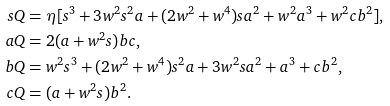Convert formula to latex. <formula><loc_0><loc_0><loc_500><loc_500>s Q & = \eta [ s ^ { 3 } + 3 w ^ { 2 } s ^ { 2 } a + ( 2 w ^ { 2 } + w ^ { 4 } ) s a ^ { 2 } + w ^ { 2 } a ^ { 3 } + w ^ { 2 } c b ^ { 2 } ] , \\ a Q & = 2 ( a + w ^ { 2 } s ) b c , \\ b Q & = w ^ { 2 } s ^ { 3 } + ( 2 w ^ { 2 } + w ^ { 4 } ) s ^ { 2 } a + 3 w ^ { 2 } s a ^ { 2 } + a ^ { 3 } + c b ^ { 2 } , \\ c Q & = ( a + w ^ { 2 } s ) b ^ { 2 } .</formula> 